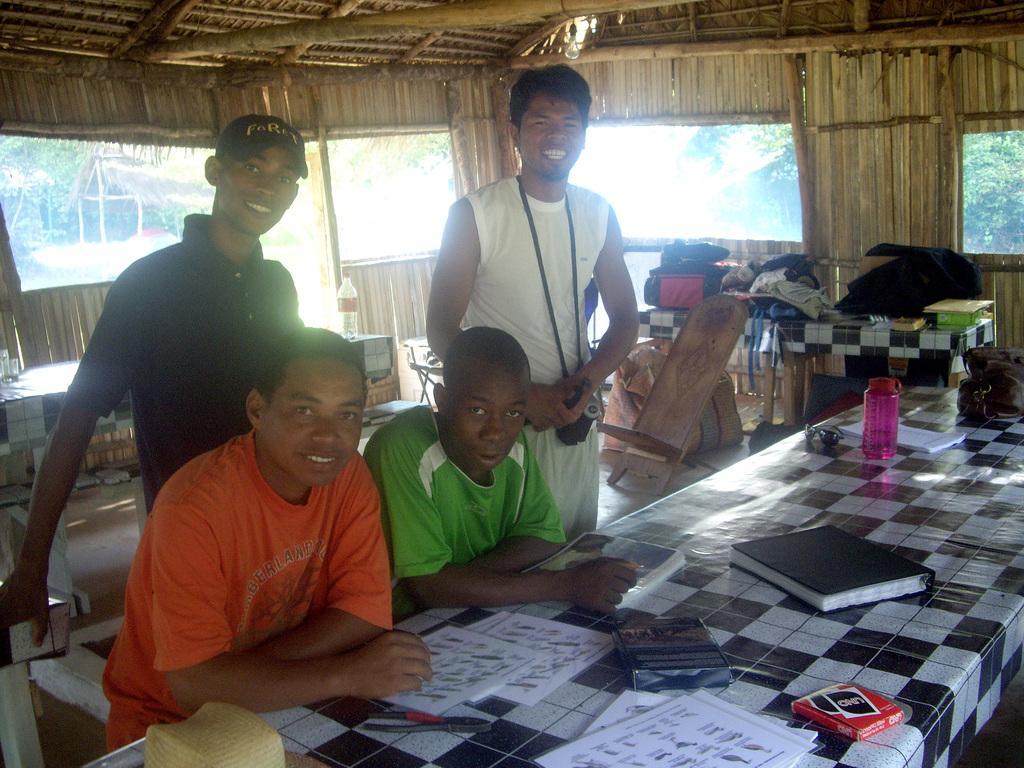Please provide a concise description of this image. In this image we can see four persons. In front of the person we can see few objects on a table. Behind the persons we can see the objects and the tables. In the background there are groups of trees and a hut. At the top we can see the roof of a hut. 